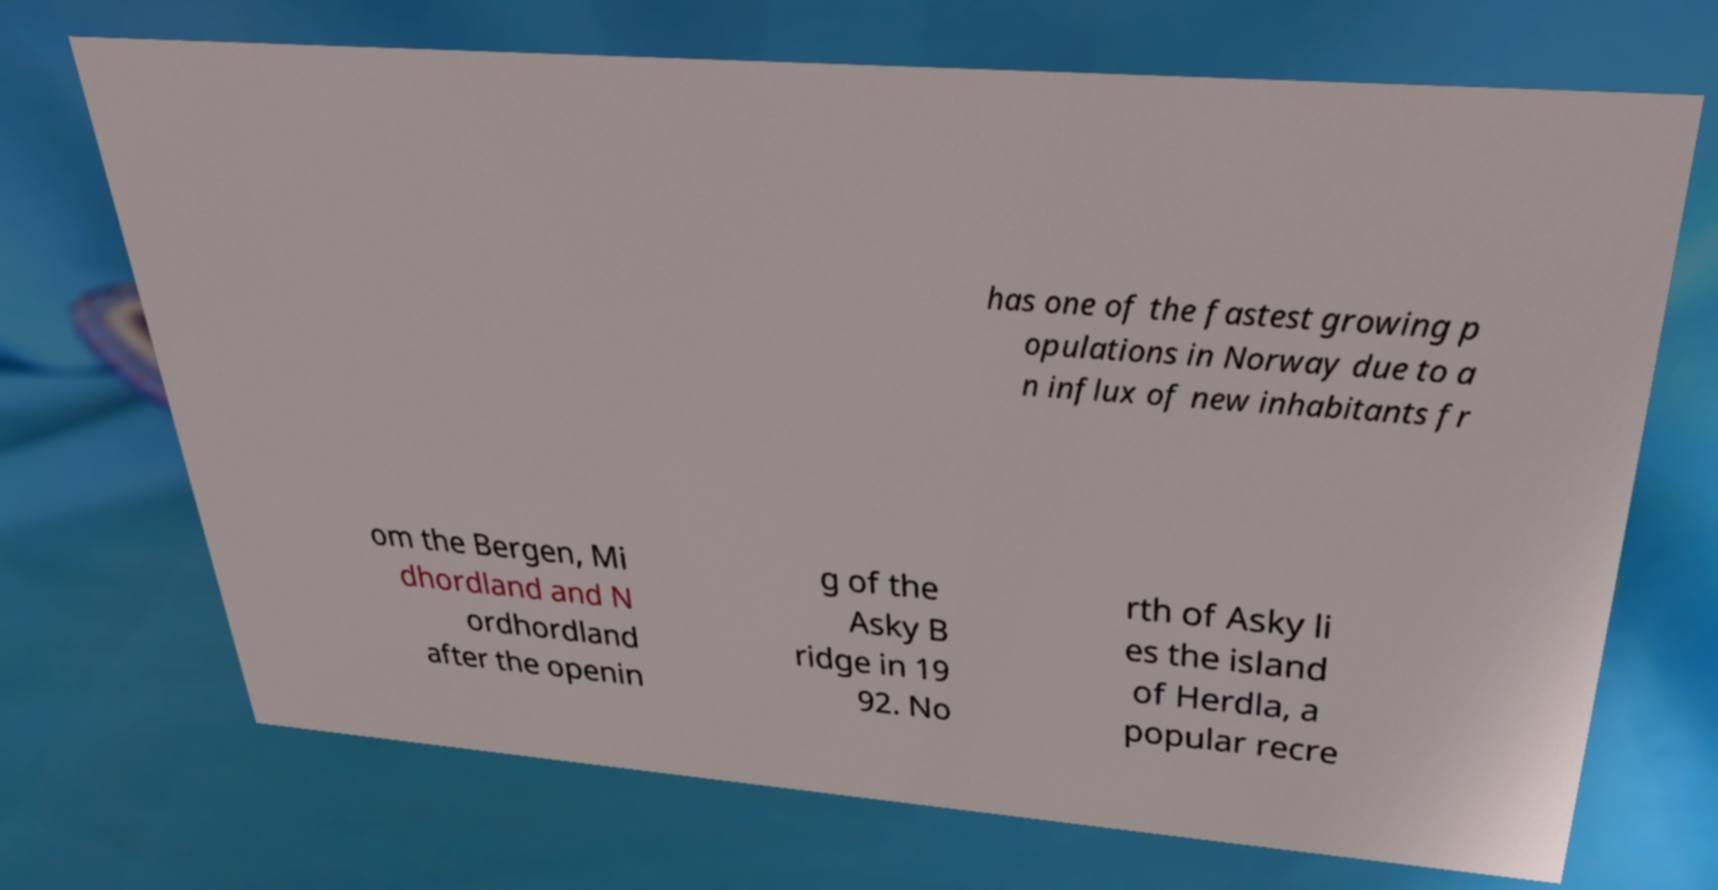Could you extract and type out the text from this image? has one of the fastest growing p opulations in Norway due to a n influx of new inhabitants fr om the Bergen, Mi dhordland and N ordhordland after the openin g of the Asky B ridge in 19 92. No rth of Asky li es the island of Herdla, a popular recre 